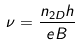Convert formula to latex. <formula><loc_0><loc_0><loc_500><loc_500>\nu = \frac { n _ { 2 D } h } { e B }</formula> 